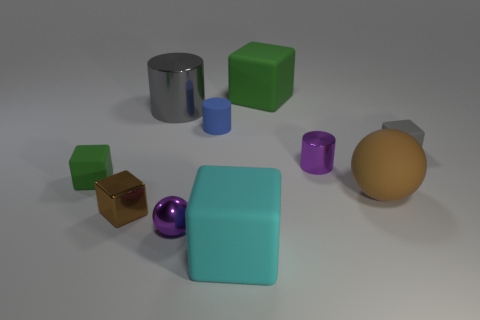Subtract all red cylinders. Subtract all blue spheres. How many cylinders are left? 3 Subtract all balls. How many objects are left? 8 Add 3 yellow rubber blocks. How many yellow rubber blocks exist? 3 Subtract 0 red blocks. How many objects are left? 10 Subtract all small green things. Subtract all spheres. How many objects are left? 7 Add 6 brown shiny cubes. How many brown shiny cubes are left? 7 